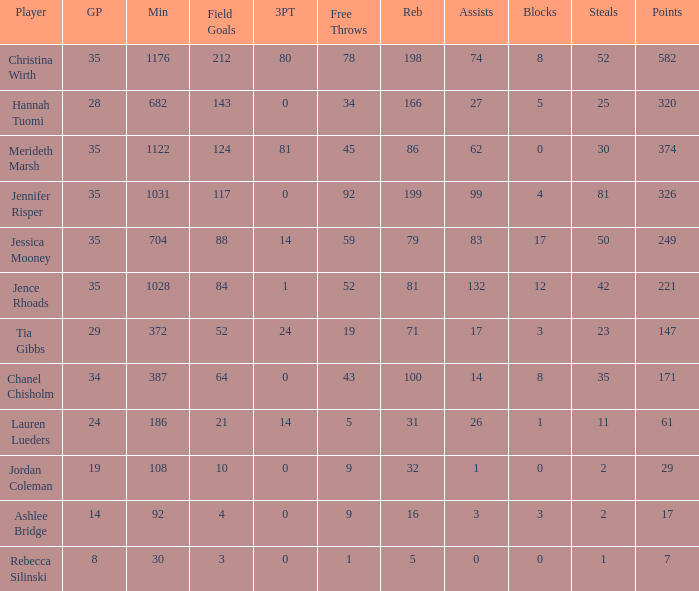What is the lowest number of 3 pointers that occured in games with 52 steals? 80.0. 